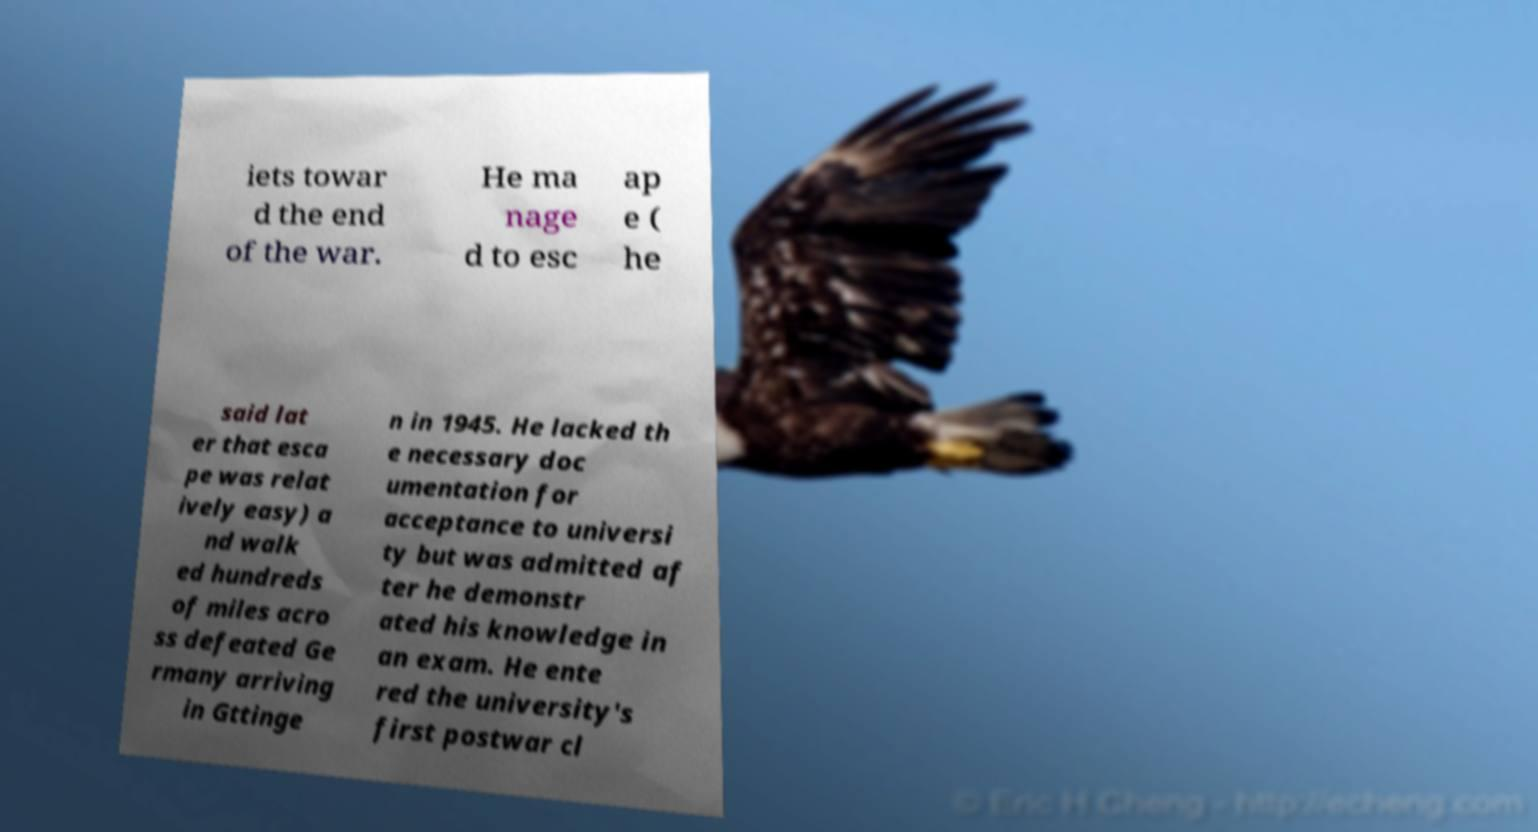Please identify and transcribe the text found in this image. iets towar d the end of the war. He ma nage d to esc ap e ( he said lat er that esca pe was relat ively easy) a nd walk ed hundreds of miles acro ss defeated Ge rmany arriving in Gttinge n in 1945. He lacked th e necessary doc umentation for acceptance to universi ty but was admitted af ter he demonstr ated his knowledge in an exam. He ente red the university's first postwar cl 